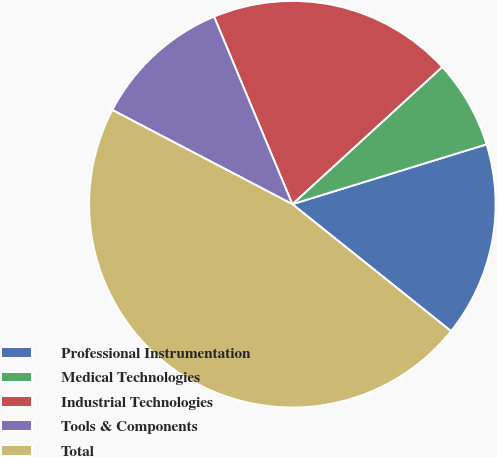<chart> <loc_0><loc_0><loc_500><loc_500><pie_chart><fcel>Professional Instrumentation<fcel>Medical Technologies<fcel>Industrial Technologies<fcel>Tools & Components<fcel>Total<nl><fcel>15.5%<fcel>7.04%<fcel>19.49%<fcel>11.03%<fcel>46.93%<nl></chart> 